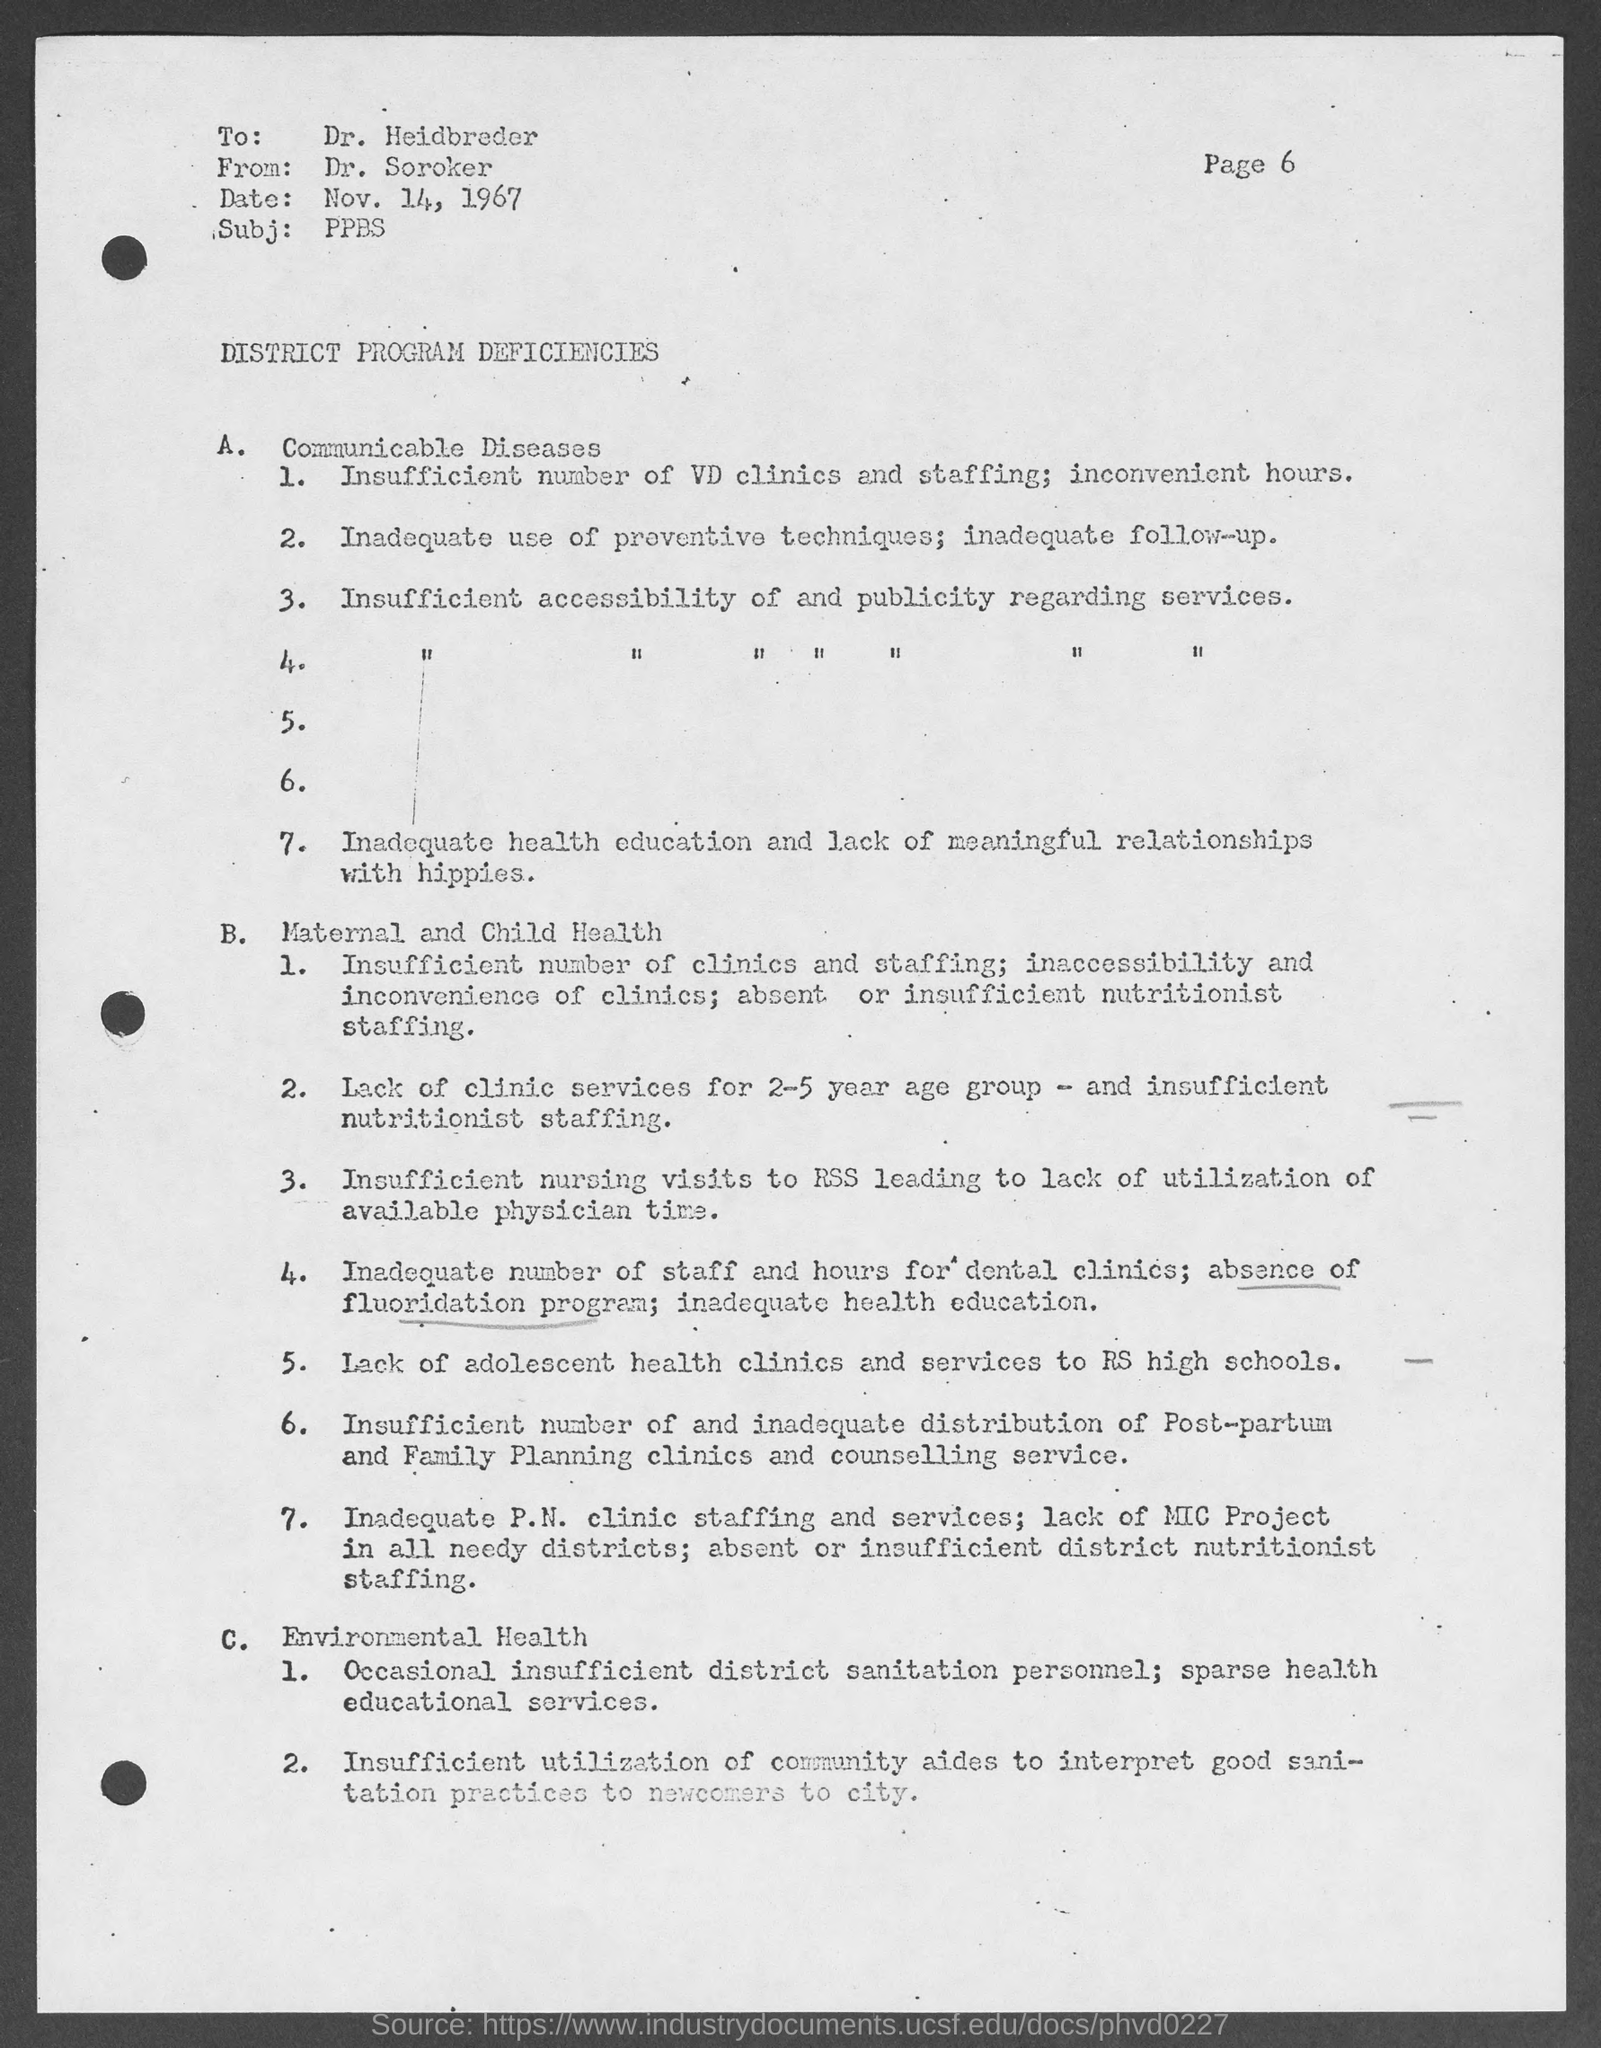Who is the receiver of this document?
Your response must be concise. Dr. Heidbreder. What is the subject mentioned in the document?
Offer a very short reply. PPBS. What is the date mentioned in this document?
Provide a succinct answer. Nov. 14, 1967. Who is the sender of this document?
Make the answer very short. Dr. Soroker. 